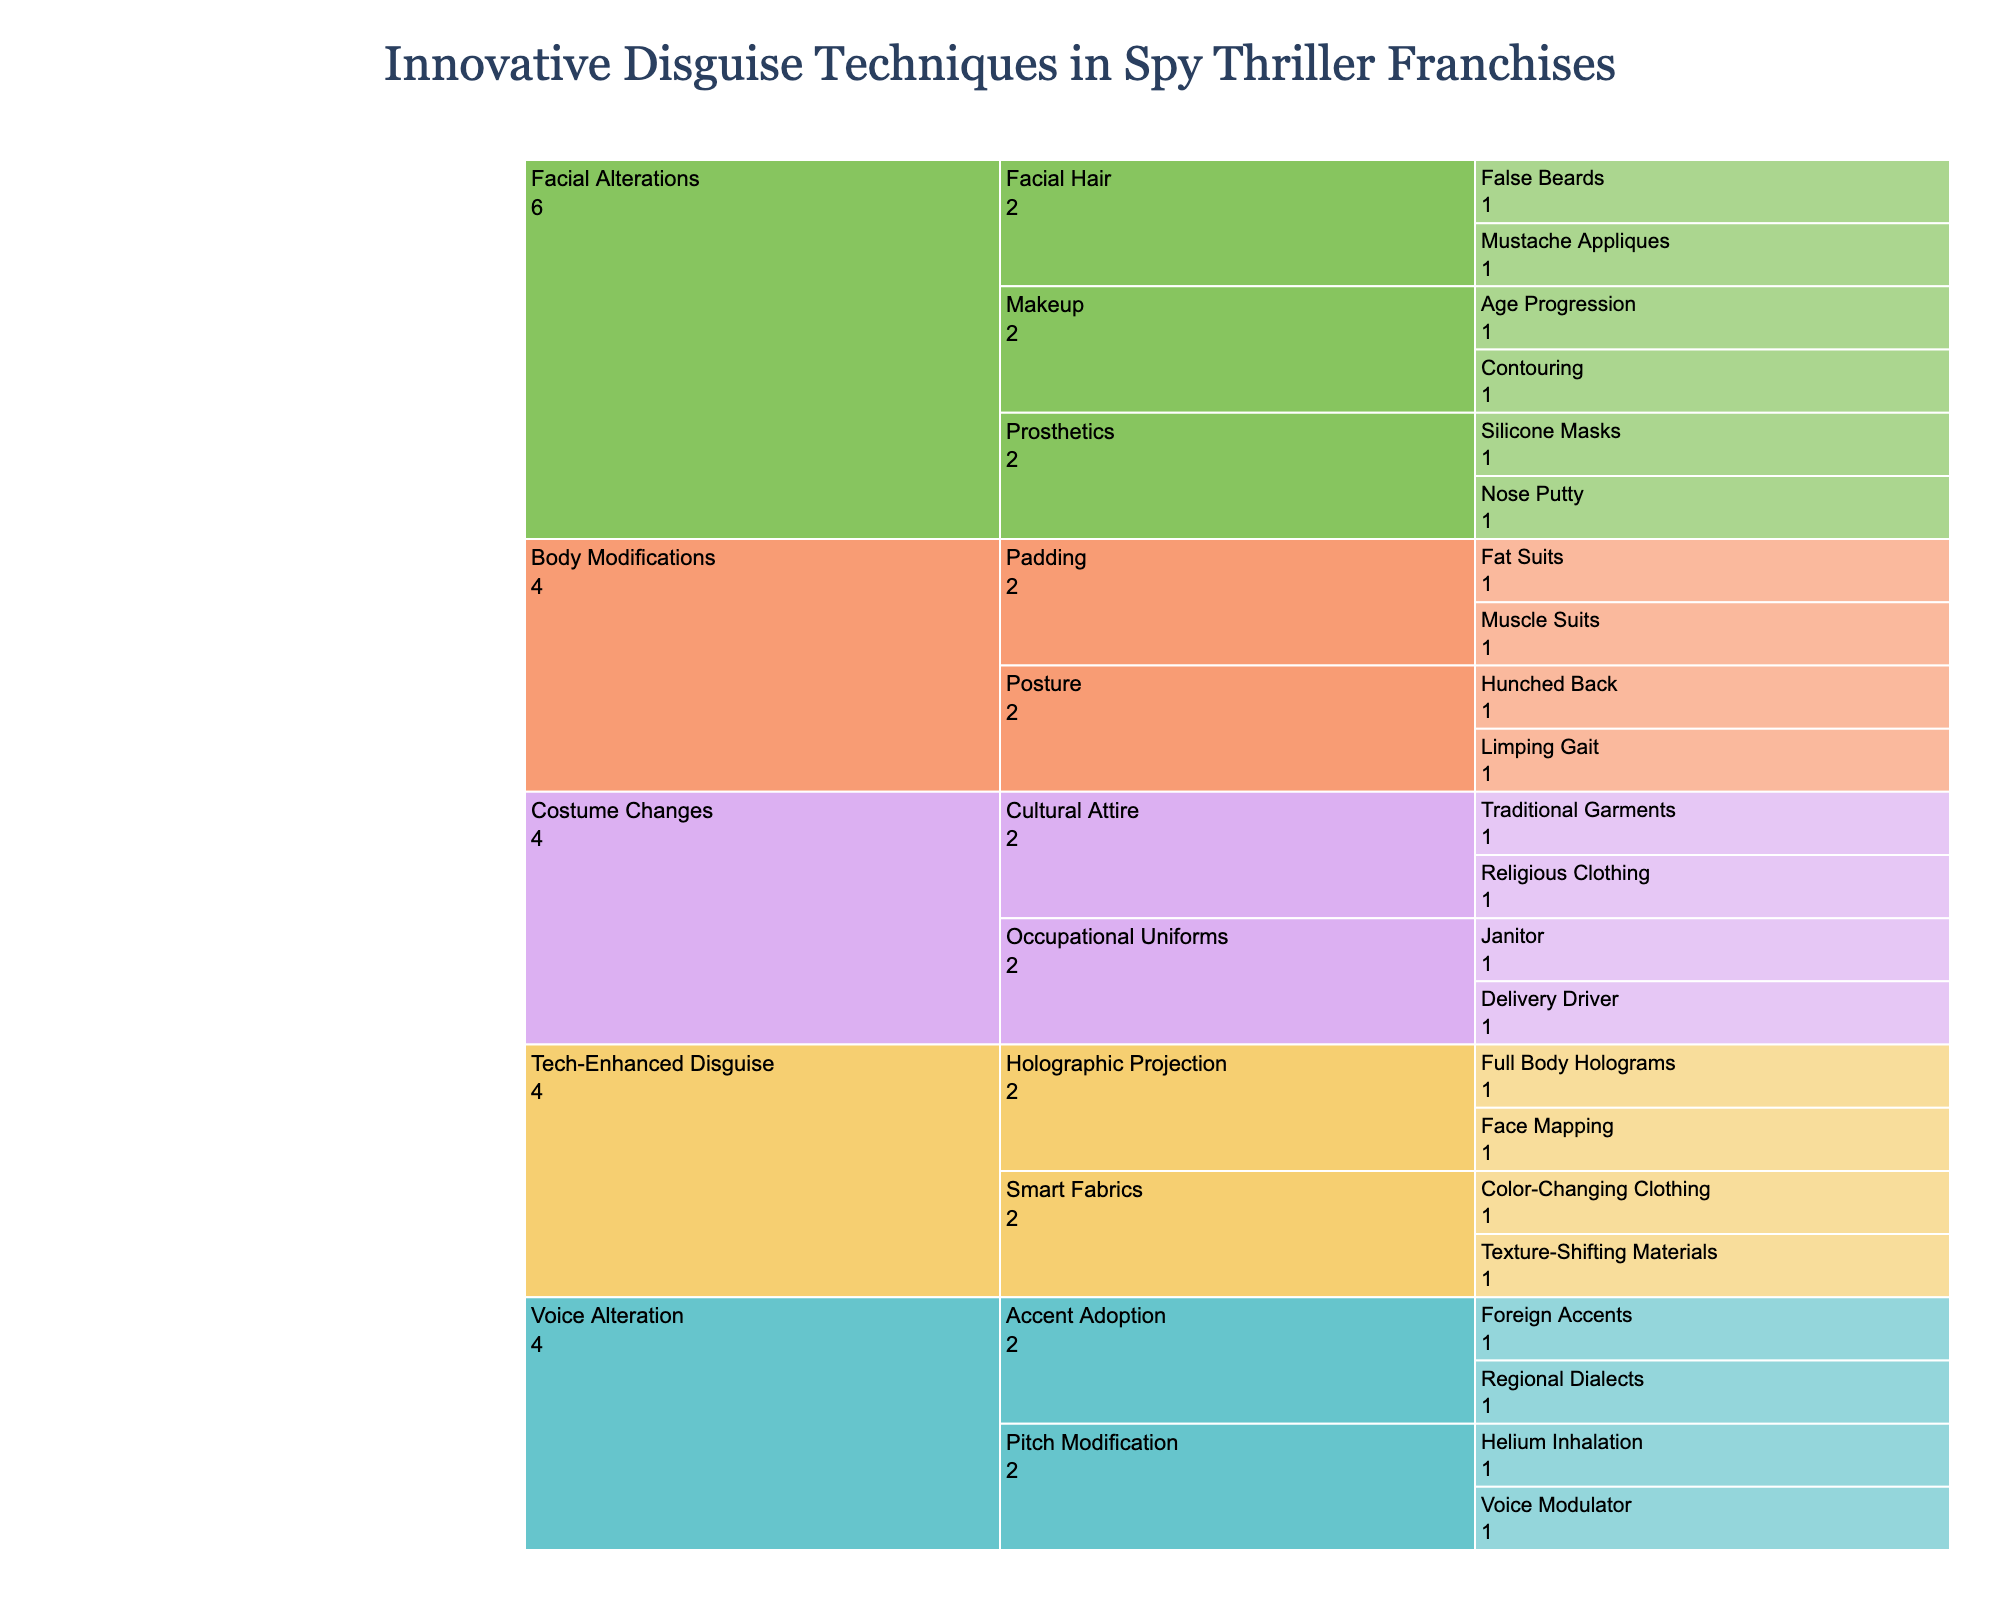What is the title of the chart? The title is displayed at the top of the chart and summarizes the main subject of the visualized data.
Answer: Innovative Disguise Techniques in Spy Thriller Franchises How many main categories are there in the chart? We count the unique main categories listed at the first level of the icicle chart.
Answer: 5 Which subcategory under "Facial Alterations" includes "Silicone Masks"? We trace the hierarchy starting from "Facial Alterations" down to the relevant subcategory that includes "Silicone Masks".
Answer: Prosthetics What is the difference in the number of techniques between "Prosthetics" and "Pitch Modification"? First, we count the techniques listed under "Prosthetics" and then count the techniques under "Pitch Modification". Finally, we subtract the smaller count from the larger count.
Answer: 0 How many techniques are under "Tech-Enhanced Disguise"? We count the total number of techniques listed under the "Tech-Enhanced Disguise" category by summing up techniques from all its subcategories.
Answer: 4 Compare the number of techniques between "Voice Alteration" and "Body Modifications". Which has more? First, we count the techniques listed under "Voice Alteration" and "Body Modifications". Then we compare the two counts to determine which is greater.
Answer: Voice Alteration What techniques are associated with "Makeup"? We identify all techniques listed under the "Makeup" subcategory within "Facial Alterations".
Answer: Contouring, Age Progression Which category uses "Smart Fabrics"? We identify the category at the highest level that contains the subcategory "Smart Fabrics".
Answer: Tech-Enhanced Disguise Are there more techniques under "Occupational Uniforms" or "Cultural Attire"? We count the techniques under each of these subcategories and then compare the counts to determine which is greater.
Answer: Equal How many total techniques are listed in the entire chart? We count all unique techniques listed across all categories and subcategories.
Answer: 20 